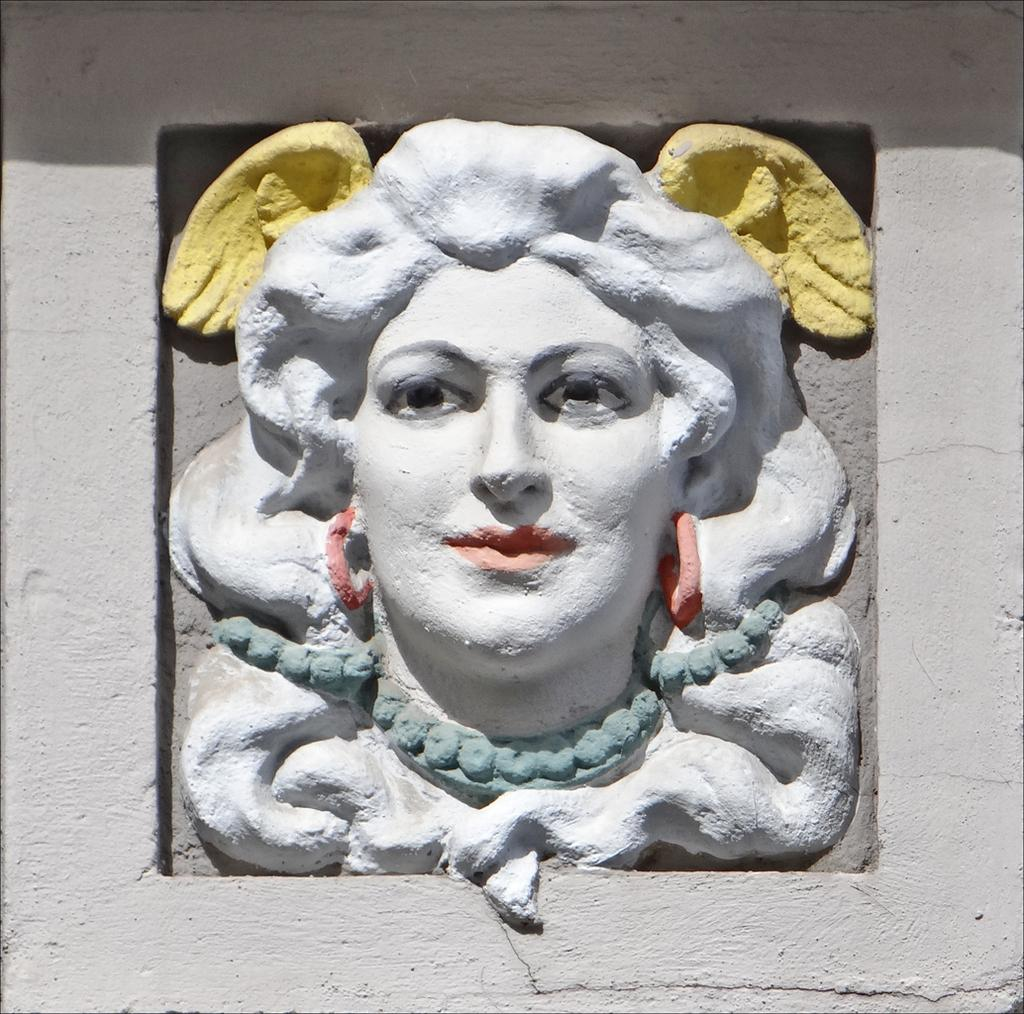What is the main subject of the image? There is a sculpture in the image. Can you describe the colors of the sculpture? The sculpture is off white, orange, blue, and yellow in color. What else can be seen in the image besides the sculpture? There is a white wall in the image. How many men are depicted in the image? There are no men present in the image; it features a sculpture and a white wall. What type of soap is used to clean the sculpture in the image? There is no soap or cleaning activity depicted in the image. 